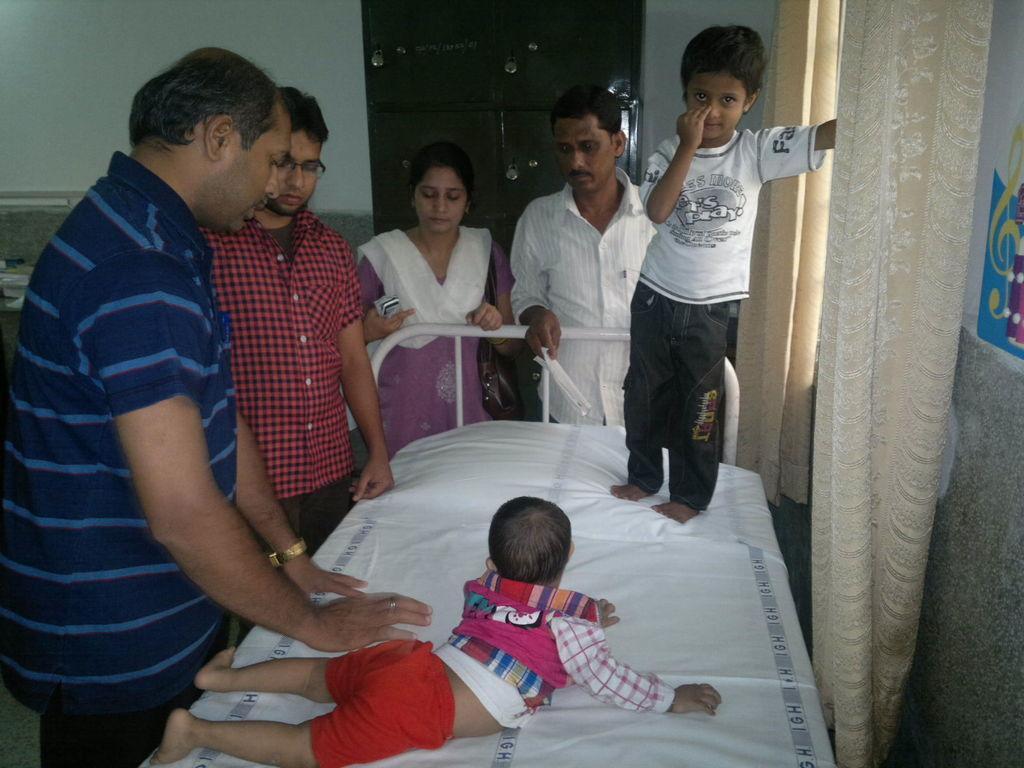Describe this image in one or two sentences. In this image I can see six people, four elders and two kids, one kid is lying on the bed and another one is standing on the bed. I can see a window, a wall with a poster and a curtain on the right hand side. I can see a wall and a metal cupboard with lockers behind the people. 